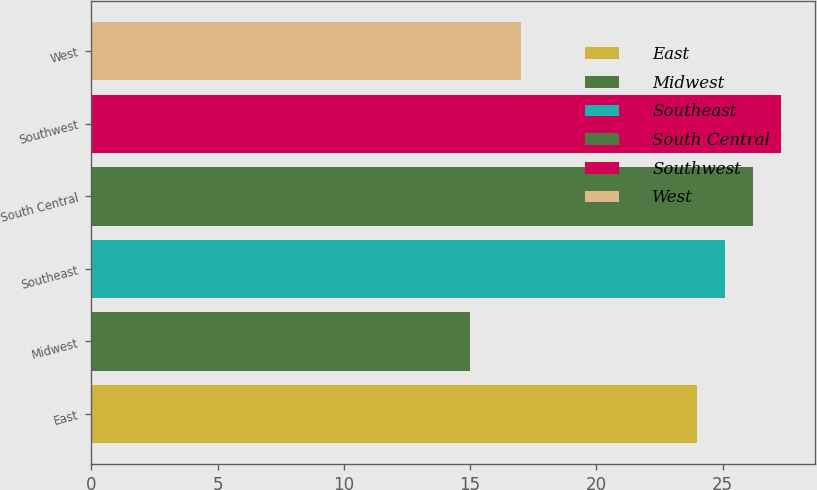Convert chart to OTSL. <chart><loc_0><loc_0><loc_500><loc_500><bar_chart><fcel>East<fcel>Midwest<fcel>Southeast<fcel>South Central<fcel>Southwest<fcel>West<nl><fcel>24<fcel>15<fcel>25.1<fcel>26.2<fcel>27.3<fcel>17<nl></chart> 